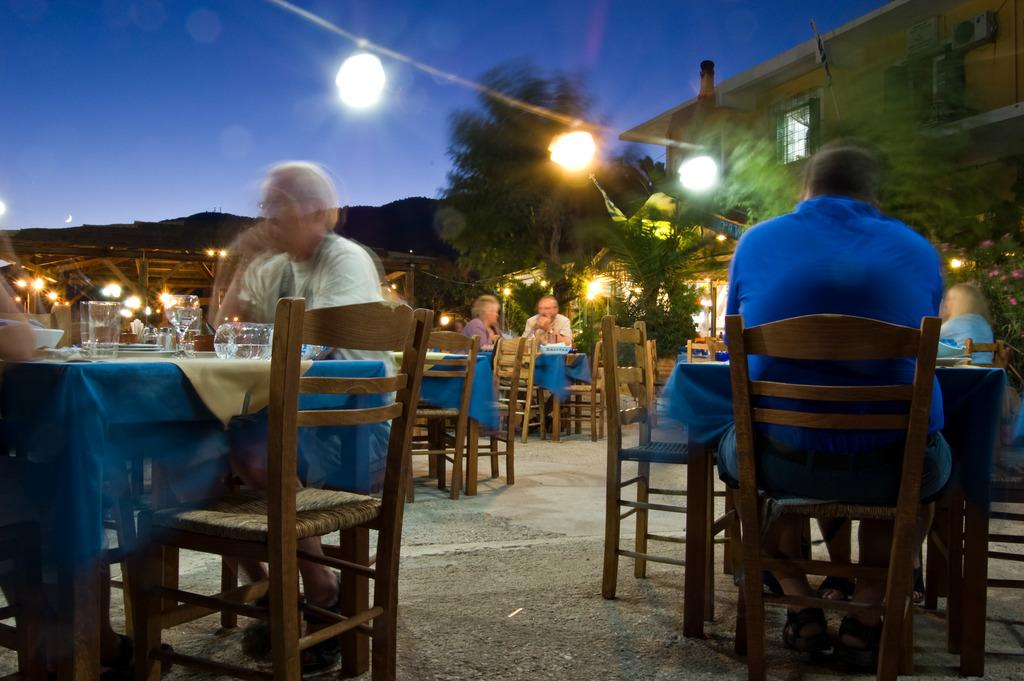What is the man on the right side of the image doing? There is a man sitting in a chair on the right side of the image. What is the man on the left side of the image doing? There is a man eating food on the left side of the image. Where is the food located? The food is on a table. What can be seen in the image that provides illumination? There are lights in the image. What type of structure is visible in the image? There is a building in the image. What part of the natural environment is visible in the image? The sky is visible in the image. How many trees are visible in the image? There are no trees visible in the image. What type of home does the man on the right side of the image live in? The image does not provide information about the man's home, only that he is sitting in a chair. 